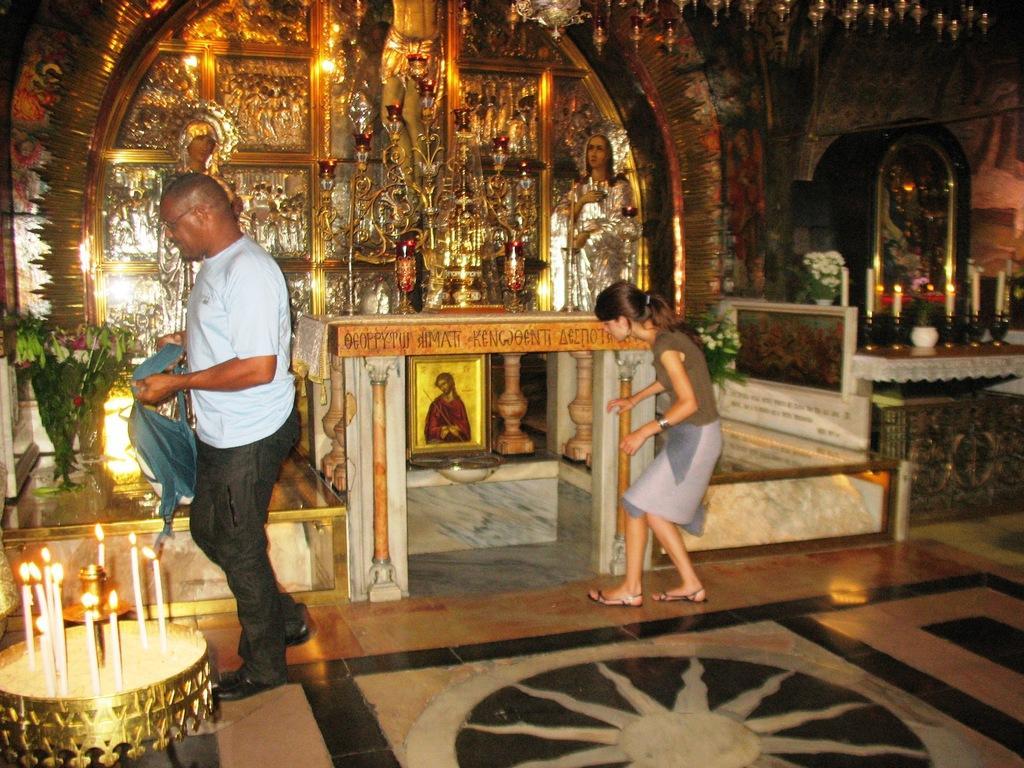Please provide a concise description of this image. In the center of the image we can see photo frame, alter, cups, sculpture, candles, table, flower pots are there. On the left side of the image a man is walking and holding a cloth. In the middle of the image a girl is there. On the left side of the image we can see candles are present on the table. At the bottom of the image floor is there. At the top of the image roof is present. On the right side of the image wall is there. 